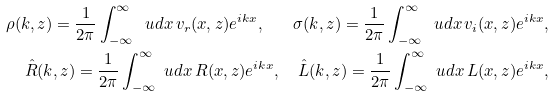Convert formula to latex. <formula><loc_0><loc_0><loc_500><loc_500>\rho ( k , z ) = \frac { 1 } { 2 \pi } \int _ { - \infty } ^ { \infty } \ u d x \, v _ { r } ( x , z ) e ^ { i k x } , \quad \sigma ( k , z ) = \frac { 1 } { 2 \pi } \int _ { - \infty } ^ { \infty } \ u d x \, v _ { i } ( x , z ) e ^ { i k x } , \\ \hat { R } ( k , z ) = \frac { 1 } { 2 \pi } \int _ { - \infty } ^ { \infty } \ u d x \, R ( x , z ) e ^ { i k x } , \quad \hat { L } ( k , z ) = \frac { 1 } { 2 \pi } \int _ { - \infty } ^ { \infty } \ u d x \, L ( x , z ) e ^ { i k x } ,</formula> 